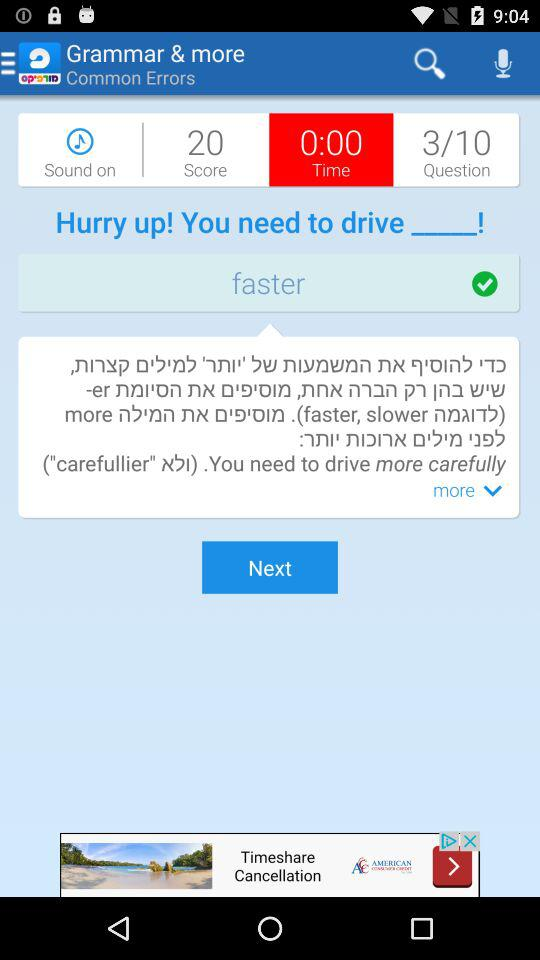What is the total number of questions? The total number of questions is 10. 